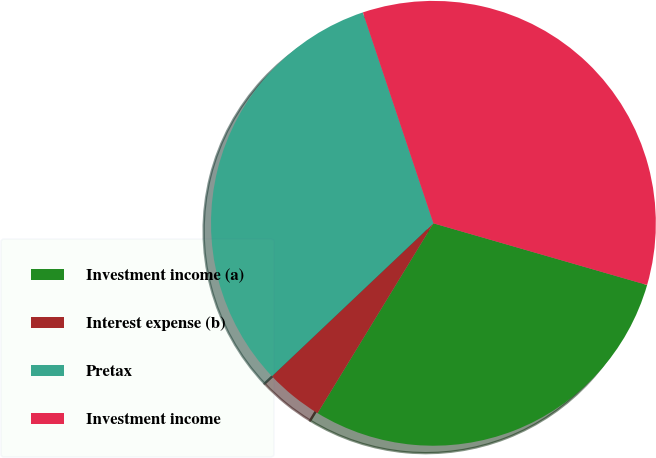Convert chart. <chart><loc_0><loc_0><loc_500><loc_500><pie_chart><fcel>Investment income (a)<fcel>Interest expense (b)<fcel>Pretax<fcel>Investment income<nl><fcel>29.25%<fcel>4.21%<fcel>31.93%<fcel>34.61%<nl></chart> 